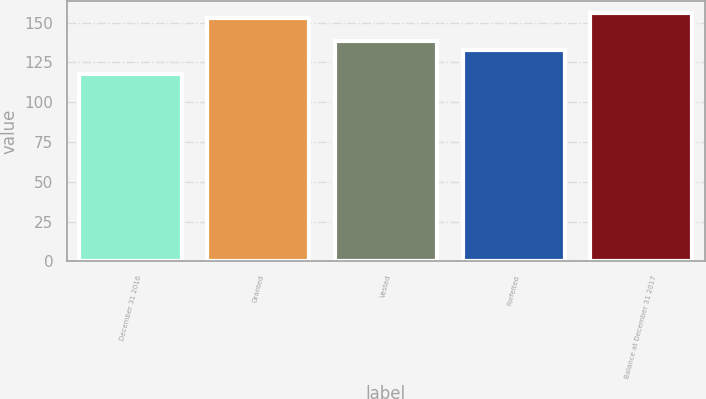<chart> <loc_0><loc_0><loc_500><loc_500><bar_chart><fcel>December 31 2016<fcel>Granted<fcel>Vested<fcel>Forfeited<fcel>Balance at December 31 2017<nl><fcel>117.83<fcel>152.61<fcel>138.62<fcel>132.8<fcel>156.09<nl></chart> 